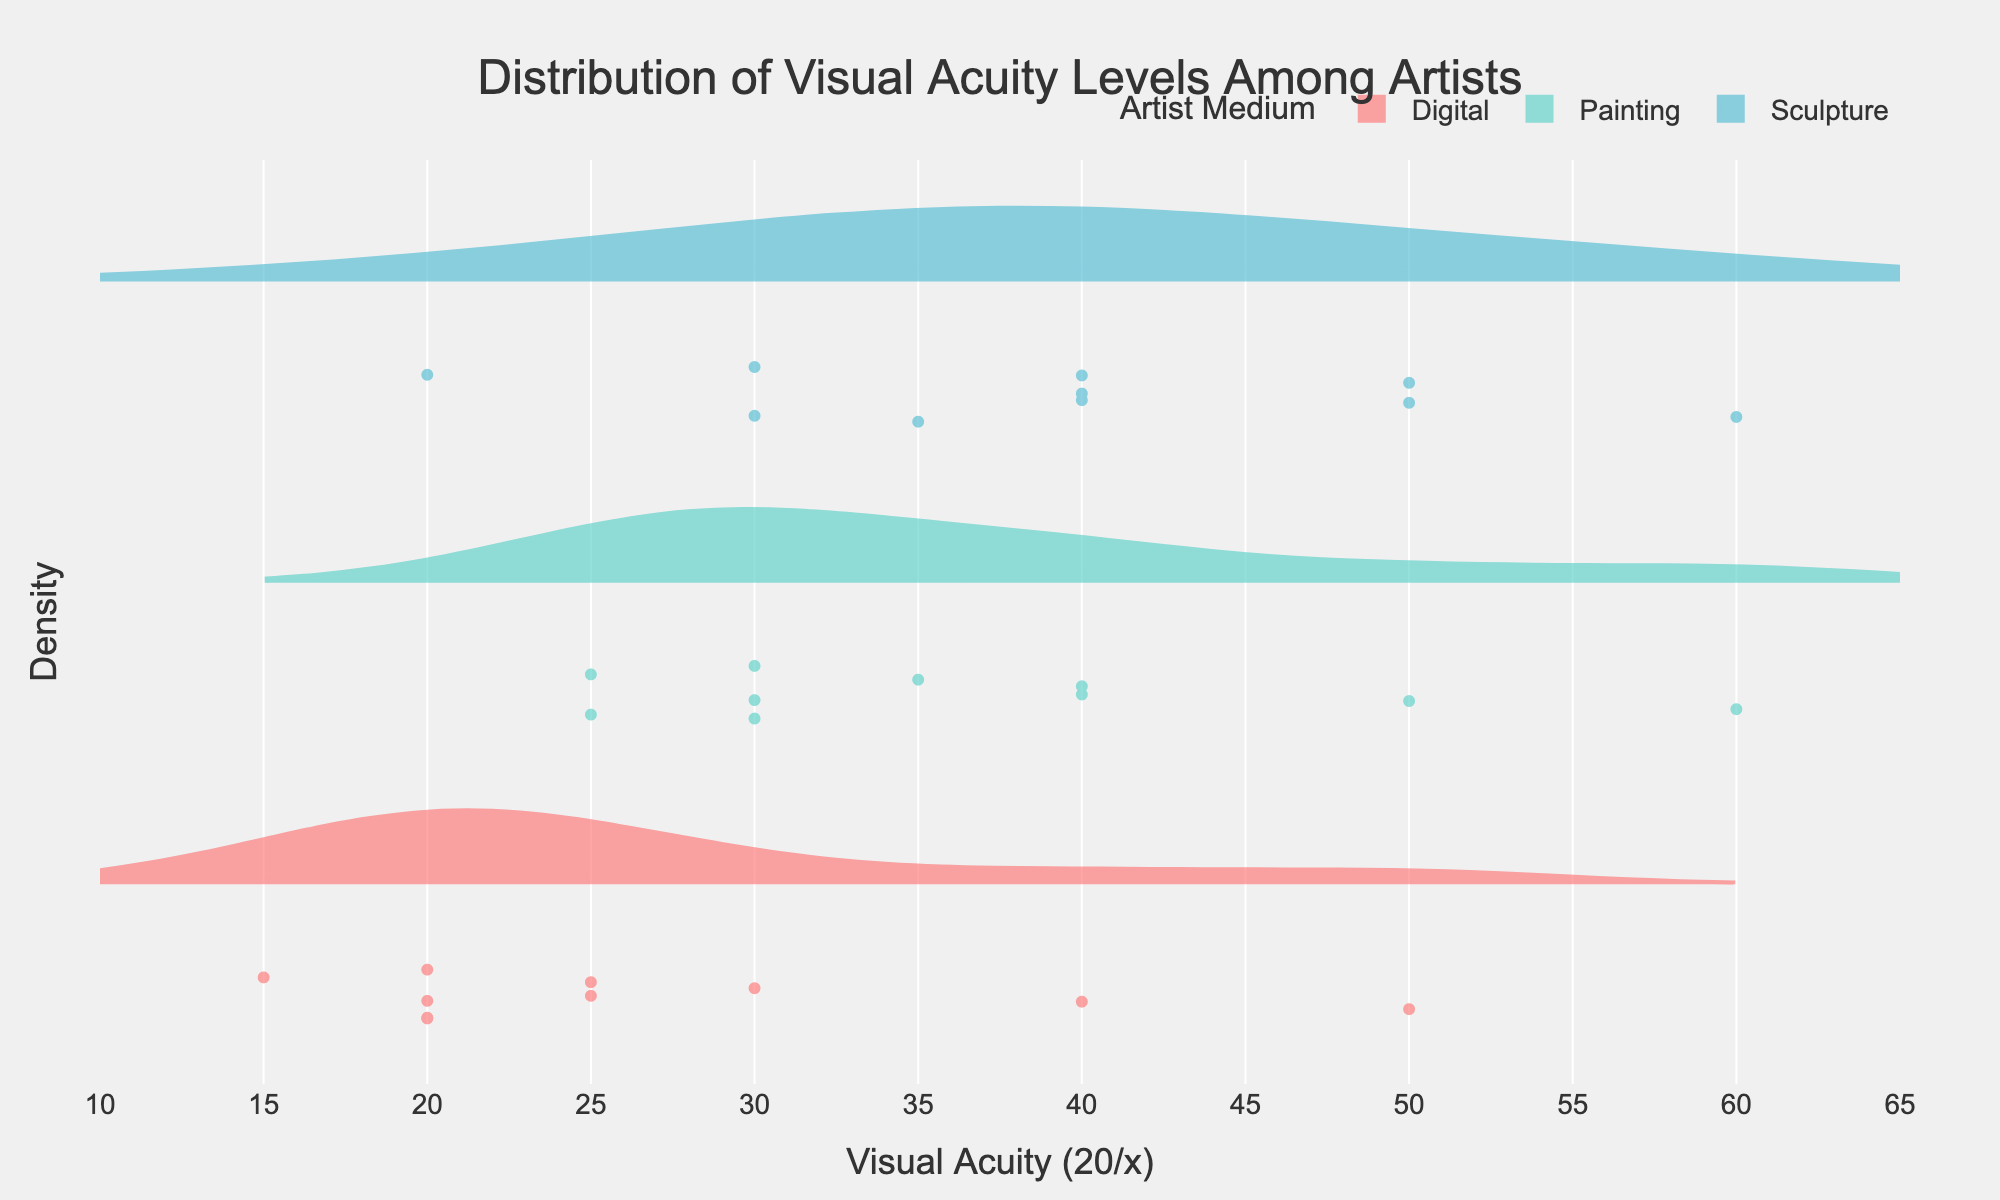What are the distinct visual acuity levels shown in the plot? The plot shows visual acuity levels that include 20/15, 20/20, 20/25, 20/30, 20/35, 20/40, 20/50, and 20/60. These values can be observed from the violin plots and associated whiskers representing different levels of visual acuity.
Answer: 20/15, 20/20, 20/25, 20/30, 20/35, 20/40, 20/50, 20/60 How does the median visual acuity level among digital artists compare to traditional painting artists? The median is represented by a horizontal line inside each violin plot. For digital artists, the median visual acuity level is at 20/20. For painting artists, the median is around 20/30. This suggests that digital artists generally have better visual acuity.
Answer: Digital artists have better median visual acuity (20/20 compared to 20/30) Which artist medium shows the widest range of visual acuity levels? To determine the widest range, we need to observe the spread of the violin plots. The painting artists show a wide range from 20/25 to 20/60. In comparison, digital artists and sculptors have more concentrated visual acuity ranges. Thus, painting has the widest range.
Answer: Painting What's the most common visual acuity level among digital artists? The density of data points in the violin plots can help determine the most common visual acuity level. For digital artists, there is a noticeable clustering around the 20/20 mark, indicating that 20/20 is the most common visual acuity level among them.
Answer: 20/20 How does the distribution of visual acuity levels among sculptors compare to painters? The distribution for sculptors indicates several peaks, notably around 20/30, 20/40, and 20/50. Painters, on the other hand, exhibit more uniform distribution among levels like 20/25, 20/30, 20/35, and 20/40. This suggests sculptors have less varied but distinct peaks in visual acuity levels compared to painters.
Answer: Sculptors have distinct peaks around 20/30, 20/40, and 20/50, while painters have a more uniform distribution How many distinct artist mediums are analyzed in the plot? The legend or the labels on the plot show the different artist mediums. There are three artist mediums represented: Digital, Painting, and Sculpture.
Answer: 3 Which visual acuity level appears to be least common across all artist mediums? By examining the density distributions and frequency of data points, visual acuity levels like 20/60 have fewer data points and show lower densities across all mediums, indicating its rarity.
Answer: 20/60 What does the violin plot's colored area represent? The colored area of each violin plot represents the distribution density of data points for each artist medium's visual acuity levels. The wider sections indicate higher frequency or density of data points at those levels.
Answer: Distribution density Which medium has the highest maximum visual acuity level, and what is that level? By observing the end points of each violin plot, we can determine the highest acuity levels. The digital artists exhibit the highest maximum visual acuity level, which is 20/15.
Answer: Digital, 20/15 